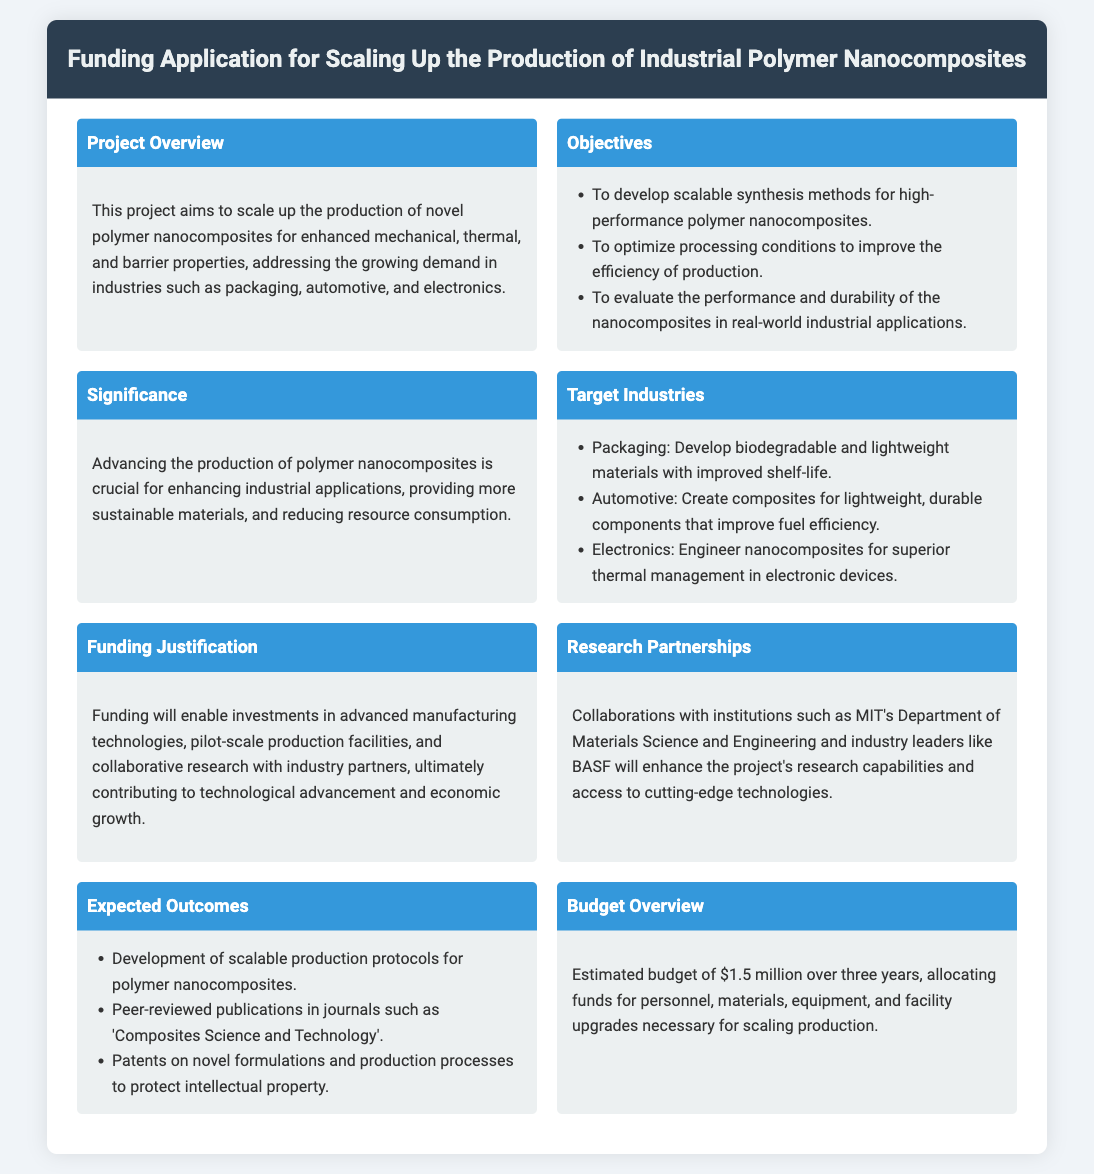What is the main goal of the project? The main goal of the project is to scale up the production of novel polymer nanocomposites for enhanced mechanical, thermal, and barrier properties.
Answer: scale up the production of novel polymer nanocomposites What is the estimated budget? The estimated budget is stated explicitly in the document as the total allocation for the project activities.
Answer: $1.5 million Which institution is mentioned as a research partner? The document lists research partnerships, and one specific institution is named as a collaborator.
Answer: MIT's Department of Materials Science and Engineering What is one target industry mentioned? The document provides examples of the industries where the developed products can be applied, requiring only one to be identified.
Answer: Packaging What is an expected outcome of the project? Expected outcomes are listed in the document, and one can be selected for the answer.
Answer: Development of scalable production protocols for polymer nanocomposites What is a reason for funding justification? The document outlines the importance of funding, highlighting a specific benefit that will come from it.
Answer: investment in advanced manufacturing technologies What type of materials are targeted for development? The document specifies the kind of materials that will be made, necessitating a brief response.
Answer: biodegradable and lightweight materials How long is the project duration? The document provides the time frame over which the budget is allocated for the research project.
Answer: three years 